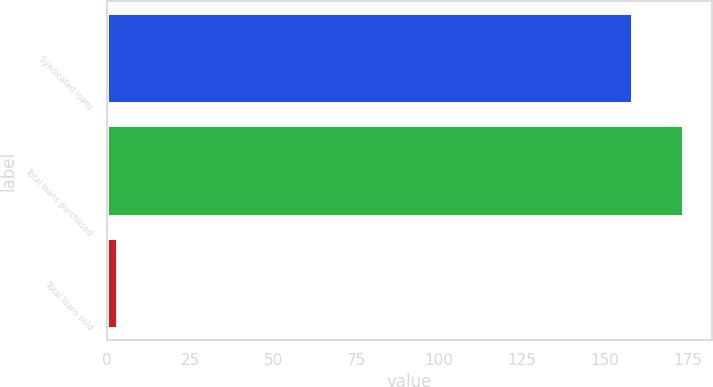Convert chart to OTSL. <chart><loc_0><loc_0><loc_500><loc_500><bar_chart><fcel>Syndicated loans<fcel>Total loans purchased<fcel>Total loans sold<nl><fcel>158<fcel>173.5<fcel>3<nl></chart> 